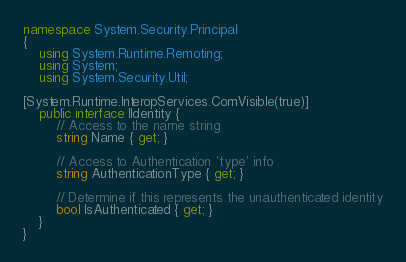<code> <loc_0><loc_0><loc_500><loc_500><_C#_>
namespace System.Security.Principal
{
    using System.Runtime.Remoting;
    using System;
    using System.Security.Util;

[System.Runtime.InteropServices.ComVisible(true)]
    public interface IIdentity {
        // Access to the name string
        string Name { get; }

        // Access to Authentication 'type' info
        string AuthenticationType { get; }

        // Determine if this represents the unauthenticated identity
        bool IsAuthenticated { get; }
    }
}
</code> 